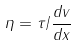<formula> <loc_0><loc_0><loc_500><loc_500>\eta = \tau / { \frac { d v } { d x } }</formula> 